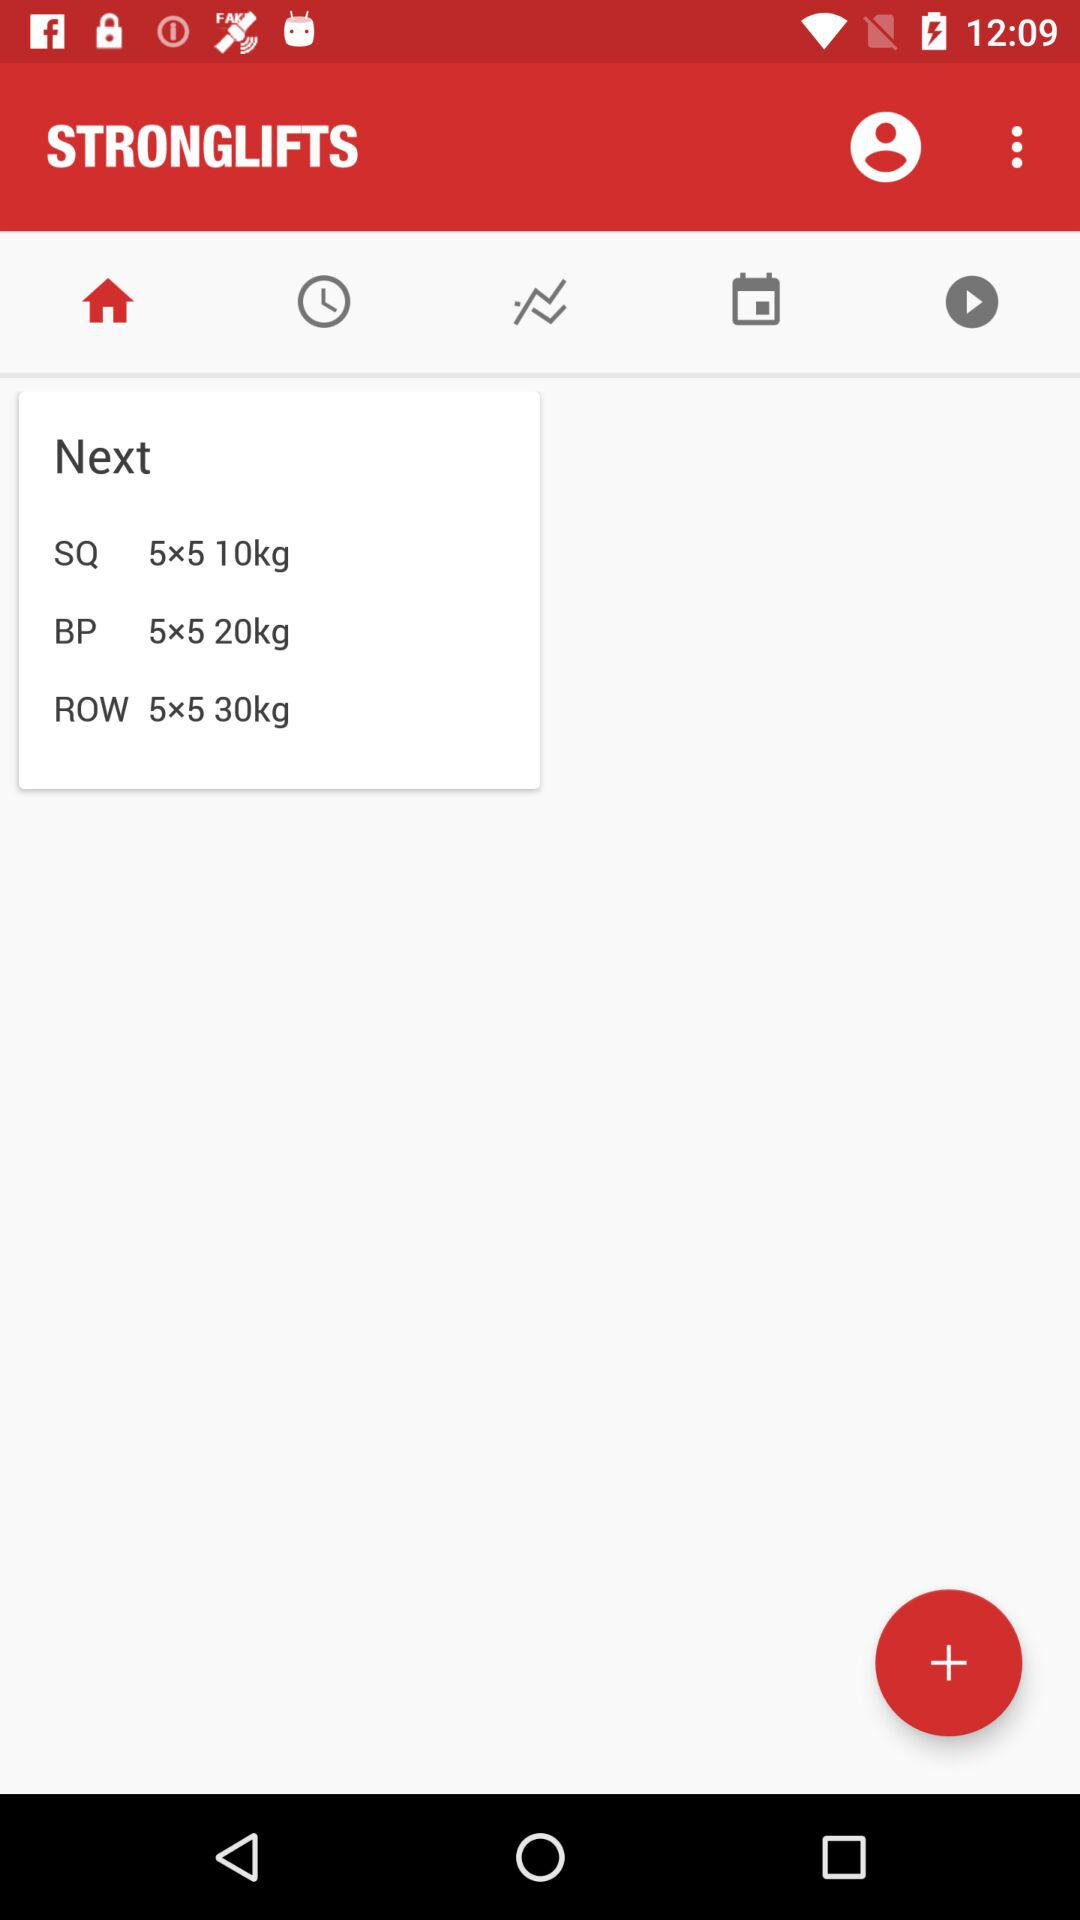How many kilograms are in the heaviest exercise?
Answer the question using a single word or phrase. 30 